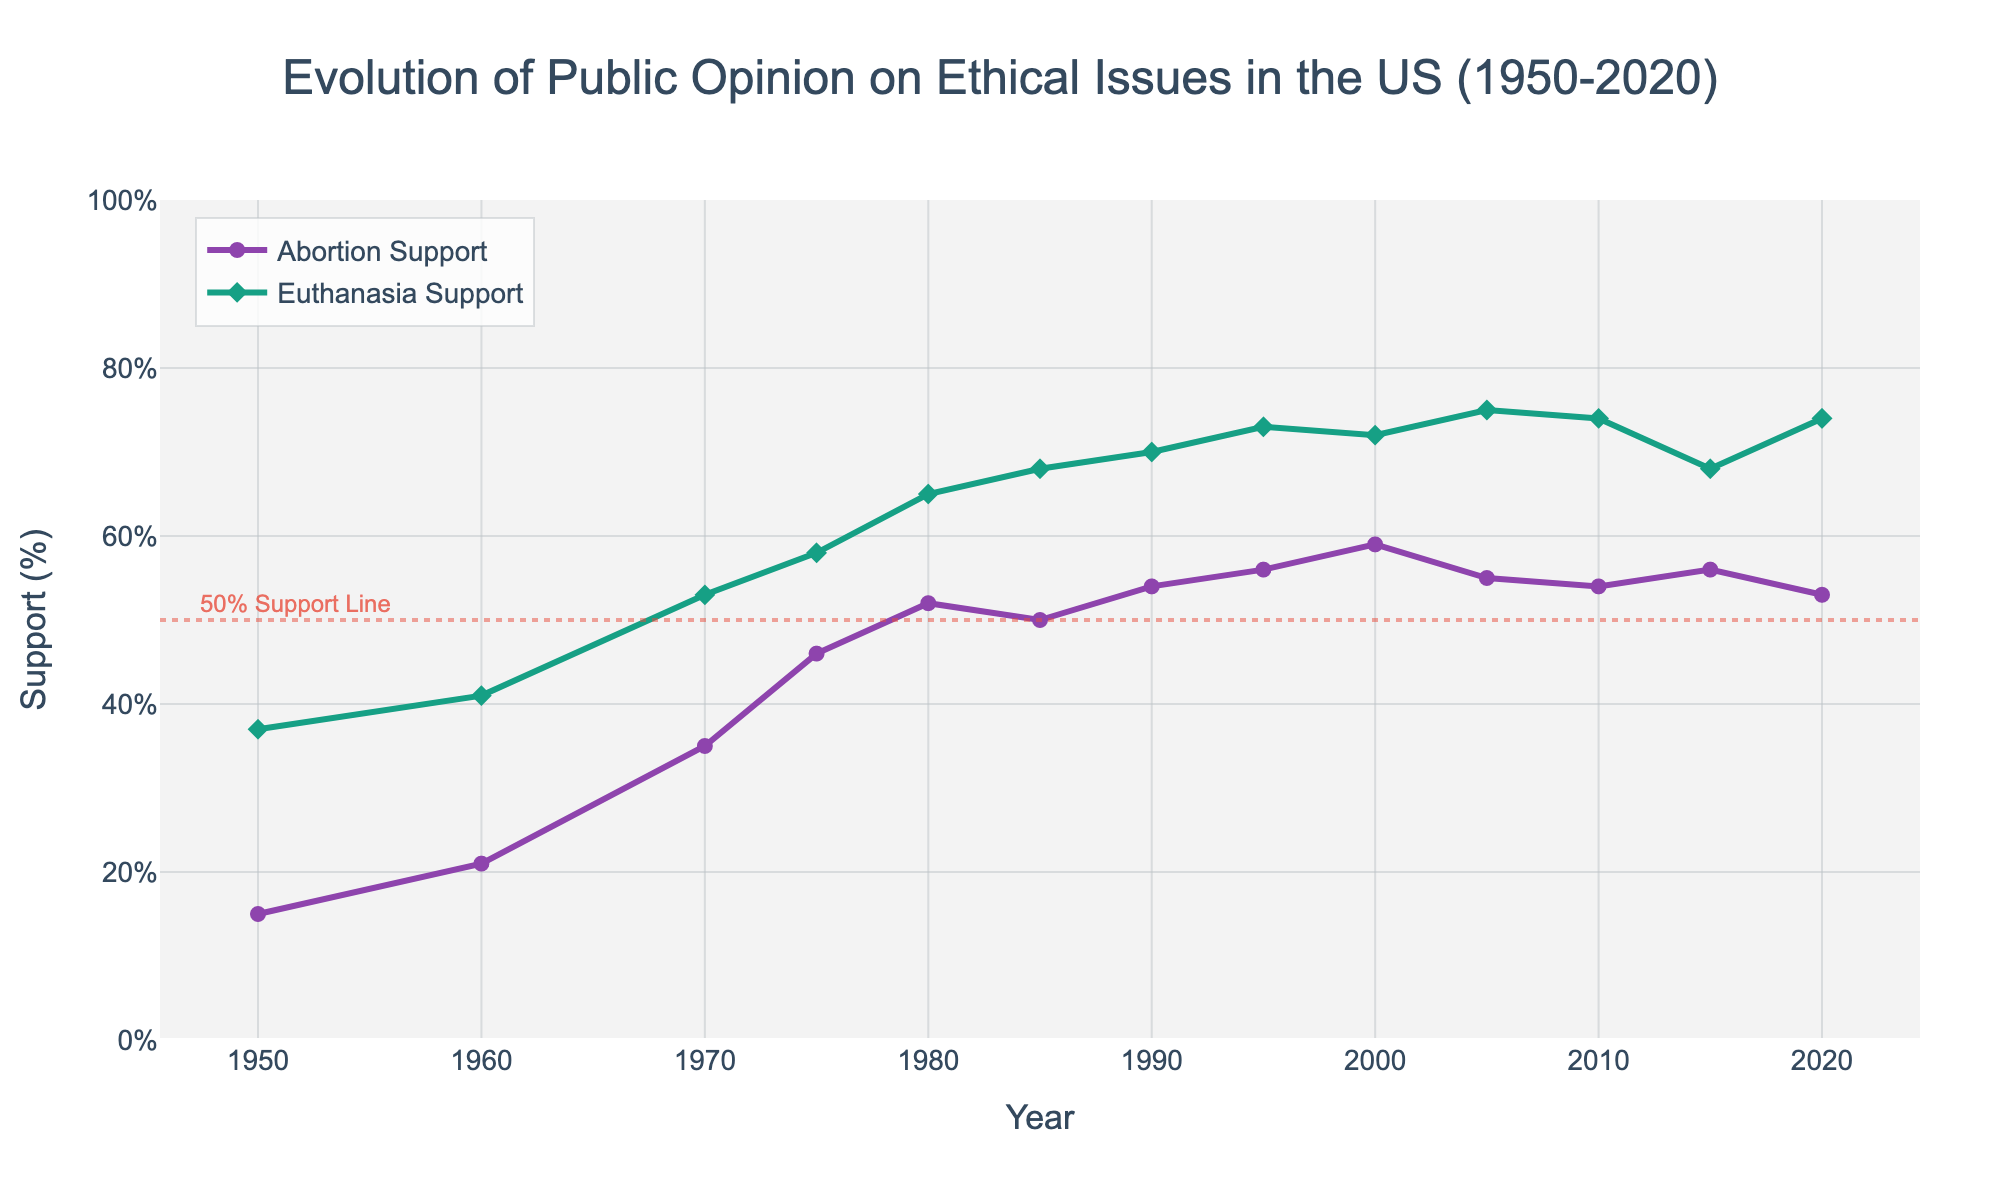How did support for euthanasia change between 1950 and 2020? To answer this, observe the line representing euthanasia support. In 1950, it was at 37%, and in 2020, it rose to 74%. So, the change is calculated as 74% - 37% = 37% points.
Answer: 37% points Between which years did abortion support see the most rapid increase? Rapid increase would be indicated by the steepest slope on the Abortion Support line. Examining the figure, the most noticeable increase occurs between 1960 and 1970, where support rose from 21% to 35%, a 14% point increase.
Answer: 1960-1970 What is the difference between abortion support and euthanasia support in 1980? In 1980, abortion support was at 52%, and euthanasia support was at 65%. The difference is calculated as 65% - 52% = 13% points.
Answer: 13% points How did abortion support in 2010 compare with that in 1975? Abortion support in 2010 was 54%, and in 1975, it was 46%. This shows an increase of 54% - 46% = 8% points.
Answer: 8% points Which year saw both abortion and euthanasia support equal or exceed the 50% support line for the first time? Examine where both lines first cross the 50% support line. For euthanasia, this happens long before 50%, but for abortion, it exceeds 50% in 1980. Thus, both lines cross 50% by 1980.
Answer: 1980 In which decade did euthanasia support increase by the smallest amount? By checking the increments on the euthanasia support line, it seems that from 2000 to 2010, the support increased by (74% - 72%) = 2% points, the smallest increment observed.
Answer: 2000-2010 What is the combined support for abortion and euthanasia in 1995? In 1995, abortion support was 56% and euthanasia support was 73%. The combined support is 56% + 73% = 129%.
Answer: 129% In which year did euthanasia support peak, according to the chart? Observing the Euthanasia Support line, the highest point is reached multiple times between 2005 and 2020 at 75%. Hence, 2005 is one of the peak years.
Answer: 2005 How did the trends in abortion support differ from those in euthanasia support over the plotted period? While both trends generally increase over time, euthanasia support shows a more consistent incremental rise after 1950. Abortion support experiences more fluctuation, particularly after 1980 where it falls occasionally.
Answer: Euthanasia showed consistent growth; abortion fluctuated more after 1980 Which support percentage grew more from 1950 to 2000, abortion or euthanasia? Abortion support in 1950 was 15%, rising to 59% in 2000 (a 44% point increase). Euthanasia support grew from 37% in 1950 to 72% in 2000 (a 35% point increase). Thus, abortion support grew more during this period.
Answer: Abortion 